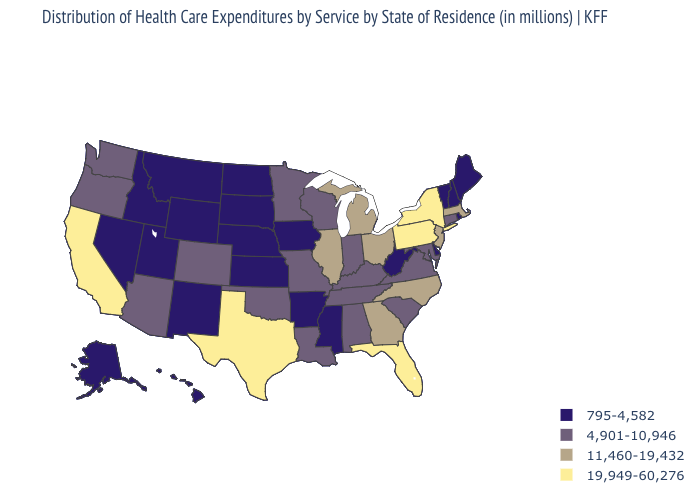Name the states that have a value in the range 19,949-60,276?
Short answer required. California, Florida, New York, Pennsylvania, Texas. What is the value of Minnesota?
Keep it brief. 4,901-10,946. Name the states that have a value in the range 11,460-19,432?
Quick response, please. Georgia, Illinois, Massachusetts, Michigan, New Jersey, North Carolina, Ohio. What is the highest value in the West ?
Answer briefly. 19,949-60,276. What is the value of Wisconsin?
Answer briefly. 4,901-10,946. Among the states that border Massachusetts , does Rhode Island have the highest value?
Answer briefly. No. What is the value of New Hampshire?
Quick response, please. 795-4,582. Name the states that have a value in the range 4,901-10,946?
Give a very brief answer. Alabama, Arizona, Colorado, Connecticut, Indiana, Kentucky, Louisiana, Maryland, Minnesota, Missouri, Oklahoma, Oregon, South Carolina, Tennessee, Virginia, Washington, Wisconsin. Does Pennsylvania have the lowest value in the USA?
Answer briefly. No. What is the value of Maine?
Concise answer only. 795-4,582. How many symbols are there in the legend?
Keep it brief. 4. Does Vermont have the lowest value in the USA?
Write a very short answer. Yes. What is the value of West Virginia?
Short answer required. 795-4,582. What is the highest value in states that border Tennessee?
Give a very brief answer. 11,460-19,432. What is the highest value in the South ?
Quick response, please. 19,949-60,276. 